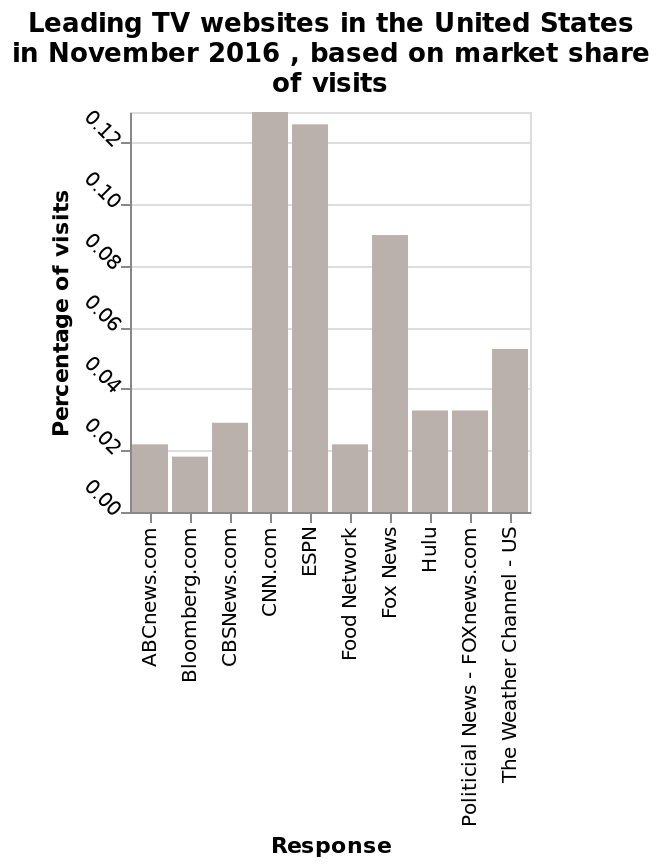<image>
What websites have seen the highest percentage of visits in 2016? CNN.com and ESPN. What is the leading TV website in the United States in November 2016?  The leading TV website in the United States in November 2016 is The Weather Channel - US. What is the significance of 2016 for CNN.com and ESPN in terms of visits? They experienced the highest percentage of visits in that year. What kind of scale is used for the categorical variable on the x-axis?  A categorical scale is used for the variable on the x-axis, ranging from ABCnews.com to The Weather Channel - US. Is a numerical scale used for the variable on the x-axis, ranging from 2 to 10? No. A categorical scale is used for the variable on the x-axis, ranging from ABCnews.com to The Weather Channel - US. 